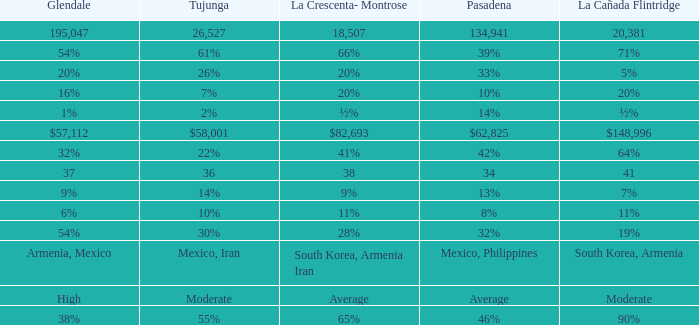What is the percentage of Glendale when La Canada Flintridge is 5%? 20%. 